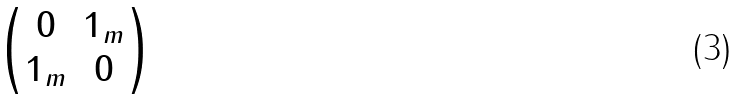<formula> <loc_0><loc_0><loc_500><loc_500>\begin{pmatrix} 0 & 1 _ { m } \\ 1 _ { m } & 0 \end{pmatrix}</formula> 